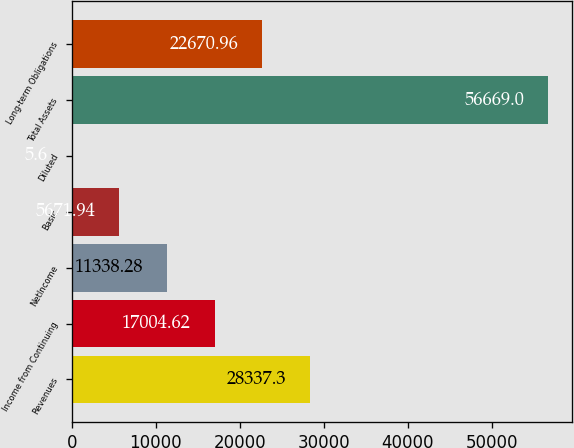Convert chart to OTSL. <chart><loc_0><loc_0><loc_500><loc_500><bar_chart><fcel>Revenues<fcel>Income from Continuing<fcel>NetIncome<fcel>Basic<fcel>Diluted<fcel>Total Assets<fcel>Long-term Obligations<nl><fcel>28337.3<fcel>17004.6<fcel>11338.3<fcel>5671.94<fcel>5.6<fcel>56669<fcel>22671<nl></chart> 